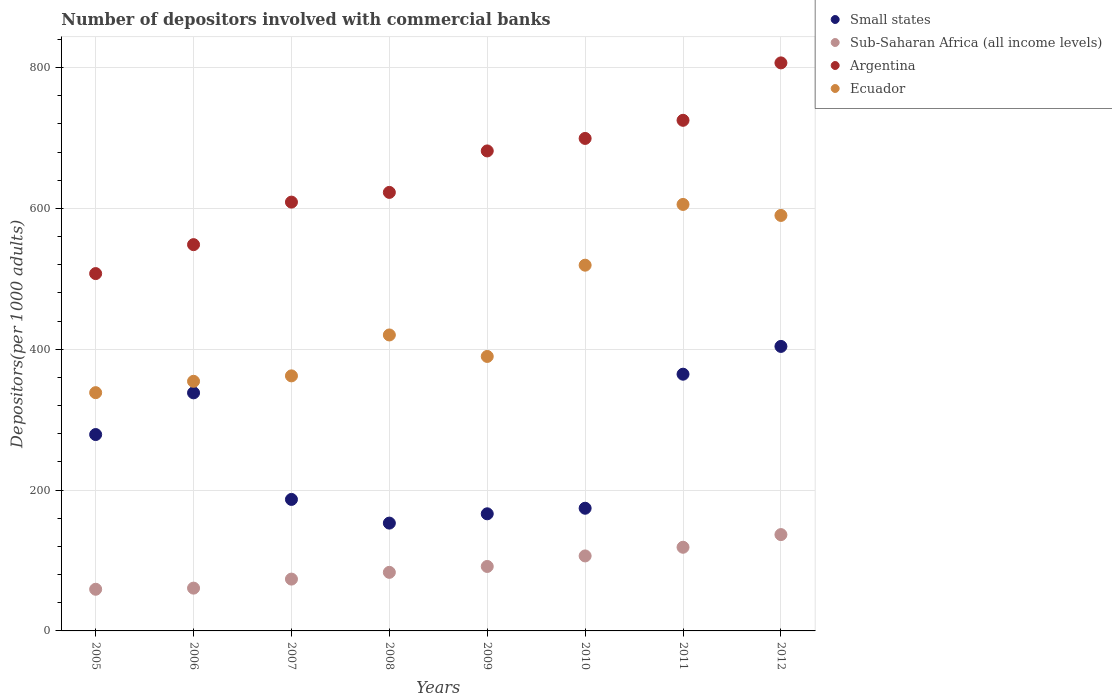How many different coloured dotlines are there?
Your answer should be very brief. 4. Is the number of dotlines equal to the number of legend labels?
Your answer should be compact. Yes. What is the number of depositors involved with commercial banks in Argentina in 2010?
Make the answer very short. 699.37. Across all years, what is the maximum number of depositors involved with commercial banks in Sub-Saharan Africa (all income levels)?
Provide a succinct answer. 136.78. Across all years, what is the minimum number of depositors involved with commercial banks in Ecuador?
Your answer should be very brief. 338.34. In which year was the number of depositors involved with commercial banks in Ecuador minimum?
Make the answer very short. 2005. What is the total number of depositors involved with commercial banks in Small states in the graph?
Offer a terse response. 2065.89. What is the difference between the number of depositors involved with commercial banks in Sub-Saharan Africa (all income levels) in 2007 and that in 2011?
Your response must be concise. -45.21. What is the difference between the number of depositors involved with commercial banks in Sub-Saharan Africa (all income levels) in 2009 and the number of depositors involved with commercial banks in Ecuador in 2010?
Keep it short and to the point. -427.82. What is the average number of depositors involved with commercial banks in Argentina per year?
Make the answer very short. 650.04. In the year 2010, what is the difference between the number of depositors involved with commercial banks in Sub-Saharan Africa (all income levels) and number of depositors involved with commercial banks in Ecuador?
Your answer should be very brief. -412.87. What is the ratio of the number of depositors involved with commercial banks in Ecuador in 2006 to that in 2007?
Give a very brief answer. 0.98. What is the difference between the highest and the second highest number of depositors involved with commercial banks in Sub-Saharan Africa (all income levels)?
Make the answer very short. 17.98. What is the difference between the highest and the lowest number of depositors involved with commercial banks in Sub-Saharan Africa (all income levels)?
Provide a short and direct response. 77.62. In how many years, is the number of depositors involved with commercial banks in Sub-Saharan Africa (all income levels) greater than the average number of depositors involved with commercial banks in Sub-Saharan Africa (all income levels) taken over all years?
Your answer should be compact. 4. Is the sum of the number of depositors involved with commercial banks in Ecuador in 2009 and 2011 greater than the maximum number of depositors involved with commercial banks in Small states across all years?
Make the answer very short. Yes. Is it the case that in every year, the sum of the number of depositors involved with commercial banks in Small states and number of depositors involved with commercial banks in Ecuador  is greater than the number of depositors involved with commercial banks in Argentina?
Keep it short and to the point. No. Does the number of depositors involved with commercial banks in Sub-Saharan Africa (all income levels) monotonically increase over the years?
Provide a succinct answer. Yes. Is the number of depositors involved with commercial banks in Sub-Saharan Africa (all income levels) strictly greater than the number of depositors involved with commercial banks in Argentina over the years?
Offer a very short reply. No. How many dotlines are there?
Provide a succinct answer. 4. How many years are there in the graph?
Your answer should be very brief. 8. What is the difference between two consecutive major ticks on the Y-axis?
Make the answer very short. 200. Are the values on the major ticks of Y-axis written in scientific E-notation?
Your response must be concise. No. Where does the legend appear in the graph?
Keep it short and to the point. Top right. How many legend labels are there?
Offer a terse response. 4. How are the legend labels stacked?
Make the answer very short. Vertical. What is the title of the graph?
Provide a short and direct response. Number of depositors involved with commercial banks. What is the label or title of the X-axis?
Keep it short and to the point. Years. What is the label or title of the Y-axis?
Make the answer very short. Depositors(per 1000 adults). What is the Depositors(per 1000 adults) of Small states in 2005?
Provide a succinct answer. 278.86. What is the Depositors(per 1000 adults) of Sub-Saharan Africa (all income levels) in 2005?
Your response must be concise. 59.17. What is the Depositors(per 1000 adults) in Argentina in 2005?
Your answer should be very brief. 507.43. What is the Depositors(per 1000 adults) in Ecuador in 2005?
Offer a very short reply. 338.34. What is the Depositors(per 1000 adults) of Small states in 2006?
Offer a terse response. 338.08. What is the Depositors(per 1000 adults) in Sub-Saharan Africa (all income levels) in 2006?
Offer a very short reply. 60.76. What is the Depositors(per 1000 adults) of Argentina in 2006?
Make the answer very short. 548.53. What is the Depositors(per 1000 adults) of Ecuador in 2006?
Ensure brevity in your answer.  354.46. What is the Depositors(per 1000 adults) of Small states in 2007?
Keep it short and to the point. 186.74. What is the Depositors(per 1000 adults) in Sub-Saharan Africa (all income levels) in 2007?
Your response must be concise. 73.6. What is the Depositors(per 1000 adults) of Argentina in 2007?
Keep it short and to the point. 608.93. What is the Depositors(per 1000 adults) in Ecuador in 2007?
Your answer should be compact. 362.19. What is the Depositors(per 1000 adults) of Small states in 2008?
Your answer should be very brief. 153.11. What is the Depositors(per 1000 adults) in Sub-Saharan Africa (all income levels) in 2008?
Give a very brief answer. 83.18. What is the Depositors(per 1000 adults) of Argentina in 2008?
Provide a succinct answer. 622.73. What is the Depositors(per 1000 adults) in Ecuador in 2008?
Ensure brevity in your answer.  420.28. What is the Depositors(per 1000 adults) in Small states in 2009?
Give a very brief answer. 166.31. What is the Depositors(per 1000 adults) of Sub-Saharan Africa (all income levels) in 2009?
Provide a succinct answer. 91.54. What is the Depositors(per 1000 adults) in Argentina in 2009?
Your response must be concise. 681.62. What is the Depositors(per 1000 adults) of Ecuador in 2009?
Ensure brevity in your answer.  389.78. What is the Depositors(per 1000 adults) in Small states in 2010?
Offer a very short reply. 174.21. What is the Depositors(per 1000 adults) in Sub-Saharan Africa (all income levels) in 2010?
Keep it short and to the point. 106.49. What is the Depositors(per 1000 adults) of Argentina in 2010?
Offer a terse response. 699.37. What is the Depositors(per 1000 adults) in Ecuador in 2010?
Make the answer very short. 519.36. What is the Depositors(per 1000 adults) in Small states in 2011?
Provide a succinct answer. 364.57. What is the Depositors(per 1000 adults) in Sub-Saharan Africa (all income levels) in 2011?
Your response must be concise. 118.8. What is the Depositors(per 1000 adults) in Argentina in 2011?
Give a very brief answer. 725.1. What is the Depositors(per 1000 adults) of Ecuador in 2011?
Provide a short and direct response. 605.63. What is the Depositors(per 1000 adults) of Small states in 2012?
Your answer should be very brief. 404.02. What is the Depositors(per 1000 adults) in Sub-Saharan Africa (all income levels) in 2012?
Provide a succinct answer. 136.78. What is the Depositors(per 1000 adults) in Argentina in 2012?
Offer a very short reply. 806.63. What is the Depositors(per 1000 adults) in Ecuador in 2012?
Offer a very short reply. 590.02. Across all years, what is the maximum Depositors(per 1000 adults) of Small states?
Your answer should be compact. 404.02. Across all years, what is the maximum Depositors(per 1000 adults) in Sub-Saharan Africa (all income levels)?
Keep it short and to the point. 136.78. Across all years, what is the maximum Depositors(per 1000 adults) in Argentina?
Your answer should be compact. 806.63. Across all years, what is the maximum Depositors(per 1000 adults) of Ecuador?
Offer a terse response. 605.63. Across all years, what is the minimum Depositors(per 1000 adults) of Small states?
Offer a terse response. 153.11. Across all years, what is the minimum Depositors(per 1000 adults) of Sub-Saharan Africa (all income levels)?
Your answer should be very brief. 59.17. Across all years, what is the minimum Depositors(per 1000 adults) in Argentina?
Make the answer very short. 507.43. Across all years, what is the minimum Depositors(per 1000 adults) in Ecuador?
Your answer should be very brief. 338.34. What is the total Depositors(per 1000 adults) in Small states in the graph?
Offer a very short reply. 2065.89. What is the total Depositors(per 1000 adults) of Sub-Saharan Africa (all income levels) in the graph?
Ensure brevity in your answer.  730.33. What is the total Depositors(per 1000 adults) of Argentina in the graph?
Provide a succinct answer. 5200.34. What is the total Depositors(per 1000 adults) of Ecuador in the graph?
Offer a terse response. 3580.07. What is the difference between the Depositors(per 1000 adults) of Small states in 2005 and that in 2006?
Your response must be concise. -59.21. What is the difference between the Depositors(per 1000 adults) of Sub-Saharan Africa (all income levels) in 2005 and that in 2006?
Offer a terse response. -1.59. What is the difference between the Depositors(per 1000 adults) in Argentina in 2005 and that in 2006?
Ensure brevity in your answer.  -41.1. What is the difference between the Depositors(per 1000 adults) of Ecuador in 2005 and that in 2006?
Ensure brevity in your answer.  -16.12. What is the difference between the Depositors(per 1000 adults) of Small states in 2005 and that in 2007?
Provide a short and direct response. 92.12. What is the difference between the Depositors(per 1000 adults) of Sub-Saharan Africa (all income levels) in 2005 and that in 2007?
Offer a very short reply. -14.43. What is the difference between the Depositors(per 1000 adults) of Argentina in 2005 and that in 2007?
Ensure brevity in your answer.  -101.5. What is the difference between the Depositors(per 1000 adults) of Ecuador in 2005 and that in 2007?
Give a very brief answer. -23.84. What is the difference between the Depositors(per 1000 adults) of Small states in 2005 and that in 2008?
Provide a short and direct response. 125.76. What is the difference between the Depositors(per 1000 adults) of Sub-Saharan Africa (all income levels) in 2005 and that in 2008?
Your answer should be very brief. -24.01. What is the difference between the Depositors(per 1000 adults) in Argentina in 2005 and that in 2008?
Your answer should be compact. -115.3. What is the difference between the Depositors(per 1000 adults) of Ecuador in 2005 and that in 2008?
Provide a succinct answer. -81.94. What is the difference between the Depositors(per 1000 adults) of Small states in 2005 and that in 2009?
Make the answer very short. 112.56. What is the difference between the Depositors(per 1000 adults) in Sub-Saharan Africa (all income levels) in 2005 and that in 2009?
Make the answer very short. -32.38. What is the difference between the Depositors(per 1000 adults) in Argentina in 2005 and that in 2009?
Offer a terse response. -174.19. What is the difference between the Depositors(per 1000 adults) of Ecuador in 2005 and that in 2009?
Offer a terse response. -51.44. What is the difference between the Depositors(per 1000 adults) of Small states in 2005 and that in 2010?
Make the answer very short. 104.65. What is the difference between the Depositors(per 1000 adults) of Sub-Saharan Africa (all income levels) in 2005 and that in 2010?
Give a very brief answer. -47.32. What is the difference between the Depositors(per 1000 adults) in Argentina in 2005 and that in 2010?
Offer a very short reply. -191.94. What is the difference between the Depositors(per 1000 adults) in Ecuador in 2005 and that in 2010?
Provide a succinct answer. -181.02. What is the difference between the Depositors(per 1000 adults) in Small states in 2005 and that in 2011?
Offer a terse response. -85.7. What is the difference between the Depositors(per 1000 adults) of Sub-Saharan Africa (all income levels) in 2005 and that in 2011?
Provide a succinct answer. -59.64. What is the difference between the Depositors(per 1000 adults) of Argentina in 2005 and that in 2011?
Your answer should be very brief. -217.67. What is the difference between the Depositors(per 1000 adults) of Ecuador in 2005 and that in 2011?
Ensure brevity in your answer.  -267.29. What is the difference between the Depositors(per 1000 adults) in Small states in 2005 and that in 2012?
Provide a short and direct response. -125.15. What is the difference between the Depositors(per 1000 adults) of Sub-Saharan Africa (all income levels) in 2005 and that in 2012?
Your response must be concise. -77.62. What is the difference between the Depositors(per 1000 adults) of Argentina in 2005 and that in 2012?
Provide a short and direct response. -299.2. What is the difference between the Depositors(per 1000 adults) of Ecuador in 2005 and that in 2012?
Your answer should be very brief. -251.68. What is the difference between the Depositors(per 1000 adults) of Small states in 2006 and that in 2007?
Your response must be concise. 151.33. What is the difference between the Depositors(per 1000 adults) of Sub-Saharan Africa (all income levels) in 2006 and that in 2007?
Your answer should be very brief. -12.83. What is the difference between the Depositors(per 1000 adults) in Argentina in 2006 and that in 2007?
Keep it short and to the point. -60.4. What is the difference between the Depositors(per 1000 adults) in Ecuador in 2006 and that in 2007?
Keep it short and to the point. -7.72. What is the difference between the Depositors(per 1000 adults) in Small states in 2006 and that in 2008?
Offer a terse response. 184.97. What is the difference between the Depositors(per 1000 adults) of Sub-Saharan Africa (all income levels) in 2006 and that in 2008?
Give a very brief answer. -22.41. What is the difference between the Depositors(per 1000 adults) in Argentina in 2006 and that in 2008?
Offer a terse response. -74.2. What is the difference between the Depositors(per 1000 adults) of Ecuador in 2006 and that in 2008?
Provide a succinct answer. -65.82. What is the difference between the Depositors(per 1000 adults) of Small states in 2006 and that in 2009?
Make the answer very short. 171.77. What is the difference between the Depositors(per 1000 adults) of Sub-Saharan Africa (all income levels) in 2006 and that in 2009?
Your response must be concise. -30.78. What is the difference between the Depositors(per 1000 adults) of Argentina in 2006 and that in 2009?
Your answer should be very brief. -133.09. What is the difference between the Depositors(per 1000 adults) of Ecuador in 2006 and that in 2009?
Your response must be concise. -35.32. What is the difference between the Depositors(per 1000 adults) of Small states in 2006 and that in 2010?
Offer a very short reply. 163.86. What is the difference between the Depositors(per 1000 adults) of Sub-Saharan Africa (all income levels) in 2006 and that in 2010?
Your answer should be compact. -45.73. What is the difference between the Depositors(per 1000 adults) of Argentina in 2006 and that in 2010?
Provide a short and direct response. -150.84. What is the difference between the Depositors(per 1000 adults) in Ecuador in 2006 and that in 2010?
Your answer should be very brief. -164.9. What is the difference between the Depositors(per 1000 adults) of Small states in 2006 and that in 2011?
Make the answer very short. -26.49. What is the difference between the Depositors(per 1000 adults) in Sub-Saharan Africa (all income levels) in 2006 and that in 2011?
Your answer should be very brief. -58.04. What is the difference between the Depositors(per 1000 adults) in Argentina in 2006 and that in 2011?
Provide a succinct answer. -176.57. What is the difference between the Depositors(per 1000 adults) in Ecuador in 2006 and that in 2011?
Ensure brevity in your answer.  -251.17. What is the difference between the Depositors(per 1000 adults) in Small states in 2006 and that in 2012?
Provide a short and direct response. -65.94. What is the difference between the Depositors(per 1000 adults) of Sub-Saharan Africa (all income levels) in 2006 and that in 2012?
Offer a very short reply. -76.02. What is the difference between the Depositors(per 1000 adults) in Argentina in 2006 and that in 2012?
Provide a succinct answer. -258.1. What is the difference between the Depositors(per 1000 adults) of Ecuador in 2006 and that in 2012?
Your answer should be very brief. -235.56. What is the difference between the Depositors(per 1000 adults) of Small states in 2007 and that in 2008?
Offer a very short reply. 33.63. What is the difference between the Depositors(per 1000 adults) of Sub-Saharan Africa (all income levels) in 2007 and that in 2008?
Offer a very short reply. -9.58. What is the difference between the Depositors(per 1000 adults) in Argentina in 2007 and that in 2008?
Your response must be concise. -13.81. What is the difference between the Depositors(per 1000 adults) in Ecuador in 2007 and that in 2008?
Give a very brief answer. -58.09. What is the difference between the Depositors(per 1000 adults) of Small states in 2007 and that in 2009?
Offer a terse response. 20.43. What is the difference between the Depositors(per 1000 adults) in Sub-Saharan Africa (all income levels) in 2007 and that in 2009?
Offer a very short reply. -17.95. What is the difference between the Depositors(per 1000 adults) in Argentina in 2007 and that in 2009?
Your answer should be compact. -72.69. What is the difference between the Depositors(per 1000 adults) of Ecuador in 2007 and that in 2009?
Your response must be concise. -27.6. What is the difference between the Depositors(per 1000 adults) in Small states in 2007 and that in 2010?
Offer a terse response. 12.53. What is the difference between the Depositors(per 1000 adults) of Sub-Saharan Africa (all income levels) in 2007 and that in 2010?
Offer a terse response. -32.89. What is the difference between the Depositors(per 1000 adults) in Argentina in 2007 and that in 2010?
Your answer should be very brief. -90.44. What is the difference between the Depositors(per 1000 adults) of Ecuador in 2007 and that in 2010?
Your answer should be compact. -157.18. What is the difference between the Depositors(per 1000 adults) in Small states in 2007 and that in 2011?
Provide a succinct answer. -177.83. What is the difference between the Depositors(per 1000 adults) in Sub-Saharan Africa (all income levels) in 2007 and that in 2011?
Your answer should be very brief. -45.21. What is the difference between the Depositors(per 1000 adults) in Argentina in 2007 and that in 2011?
Your response must be concise. -116.18. What is the difference between the Depositors(per 1000 adults) of Ecuador in 2007 and that in 2011?
Your answer should be very brief. -243.45. What is the difference between the Depositors(per 1000 adults) of Small states in 2007 and that in 2012?
Your answer should be very brief. -217.28. What is the difference between the Depositors(per 1000 adults) of Sub-Saharan Africa (all income levels) in 2007 and that in 2012?
Your answer should be very brief. -63.19. What is the difference between the Depositors(per 1000 adults) of Argentina in 2007 and that in 2012?
Offer a terse response. -197.71. What is the difference between the Depositors(per 1000 adults) in Ecuador in 2007 and that in 2012?
Your answer should be very brief. -227.83. What is the difference between the Depositors(per 1000 adults) of Small states in 2008 and that in 2009?
Your answer should be compact. -13.2. What is the difference between the Depositors(per 1000 adults) in Sub-Saharan Africa (all income levels) in 2008 and that in 2009?
Provide a short and direct response. -8.37. What is the difference between the Depositors(per 1000 adults) of Argentina in 2008 and that in 2009?
Give a very brief answer. -58.89. What is the difference between the Depositors(per 1000 adults) in Ecuador in 2008 and that in 2009?
Keep it short and to the point. 30.5. What is the difference between the Depositors(per 1000 adults) of Small states in 2008 and that in 2010?
Your answer should be very brief. -21.11. What is the difference between the Depositors(per 1000 adults) of Sub-Saharan Africa (all income levels) in 2008 and that in 2010?
Provide a succinct answer. -23.31. What is the difference between the Depositors(per 1000 adults) of Argentina in 2008 and that in 2010?
Keep it short and to the point. -76.64. What is the difference between the Depositors(per 1000 adults) in Ecuador in 2008 and that in 2010?
Provide a short and direct response. -99.08. What is the difference between the Depositors(per 1000 adults) in Small states in 2008 and that in 2011?
Make the answer very short. -211.46. What is the difference between the Depositors(per 1000 adults) of Sub-Saharan Africa (all income levels) in 2008 and that in 2011?
Ensure brevity in your answer.  -35.63. What is the difference between the Depositors(per 1000 adults) in Argentina in 2008 and that in 2011?
Give a very brief answer. -102.37. What is the difference between the Depositors(per 1000 adults) in Ecuador in 2008 and that in 2011?
Your response must be concise. -185.35. What is the difference between the Depositors(per 1000 adults) of Small states in 2008 and that in 2012?
Your response must be concise. -250.91. What is the difference between the Depositors(per 1000 adults) in Sub-Saharan Africa (all income levels) in 2008 and that in 2012?
Your answer should be compact. -53.61. What is the difference between the Depositors(per 1000 adults) in Argentina in 2008 and that in 2012?
Give a very brief answer. -183.9. What is the difference between the Depositors(per 1000 adults) in Ecuador in 2008 and that in 2012?
Provide a short and direct response. -169.74. What is the difference between the Depositors(per 1000 adults) in Small states in 2009 and that in 2010?
Your answer should be very brief. -7.91. What is the difference between the Depositors(per 1000 adults) of Sub-Saharan Africa (all income levels) in 2009 and that in 2010?
Provide a succinct answer. -14.95. What is the difference between the Depositors(per 1000 adults) in Argentina in 2009 and that in 2010?
Provide a short and direct response. -17.75. What is the difference between the Depositors(per 1000 adults) in Ecuador in 2009 and that in 2010?
Your answer should be compact. -129.58. What is the difference between the Depositors(per 1000 adults) in Small states in 2009 and that in 2011?
Offer a terse response. -198.26. What is the difference between the Depositors(per 1000 adults) of Sub-Saharan Africa (all income levels) in 2009 and that in 2011?
Provide a short and direct response. -27.26. What is the difference between the Depositors(per 1000 adults) in Argentina in 2009 and that in 2011?
Your response must be concise. -43.48. What is the difference between the Depositors(per 1000 adults) in Ecuador in 2009 and that in 2011?
Offer a terse response. -215.85. What is the difference between the Depositors(per 1000 adults) in Small states in 2009 and that in 2012?
Your answer should be very brief. -237.71. What is the difference between the Depositors(per 1000 adults) of Sub-Saharan Africa (all income levels) in 2009 and that in 2012?
Ensure brevity in your answer.  -45.24. What is the difference between the Depositors(per 1000 adults) in Argentina in 2009 and that in 2012?
Keep it short and to the point. -125.01. What is the difference between the Depositors(per 1000 adults) of Ecuador in 2009 and that in 2012?
Your answer should be very brief. -200.24. What is the difference between the Depositors(per 1000 adults) in Small states in 2010 and that in 2011?
Keep it short and to the point. -190.35. What is the difference between the Depositors(per 1000 adults) of Sub-Saharan Africa (all income levels) in 2010 and that in 2011?
Provide a succinct answer. -12.31. What is the difference between the Depositors(per 1000 adults) in Argentina in 2010 and that in 2011?
Your answer should be very brief. -25.73. What is the difference between the Depositors(per 1000 adults) in Ecuador in 2010 and that in 2011?
Give a very brief answer. -86.27. What is the difference between the Depositors(per 1000 adults) of Small states in 2010 and that in 2012?
Provide a short and direct response. -229.8. What is the difference between the Depositors(per 1000 adults) in Sub-Saharan Africa (all income levels) in 2010 and that in 2012?
Your response must be concise. -30.29. What is the difference between the Depositors(per 1000 adults) of Argentina in 2010 and that in 2012?
Provide a succinct answer. -107.26. What is the difference between the Depositors(per 1000 adults) in Ecuador in 2010 and that in 2012?
Provide a short and direct response. -70.66. What is the difference between the Depositors(per 1000 adults) in Small states in 2011 and that in 2012?
Provide a succinct answer. -39.45. What is the difference between the Depositors(per 1000 adults) in Sub-Saharan Africa (all income levels) in 2011 and that in 2012?
Make the answer very short. -17.98. What is the difference between the Depositors(per 1000 adults) in Argentina in 2011 and that in 2012?
Provide a short and direct response. -81.53. What is the difference between the Depositors(per 1000 adults) of Ecuador in 2011 and that in 2012?
Keep it short and to the point. 15.61. What is the difference between the Depositors(per 1000 adults) of Small states in 2005 and the Depositors(per 1000 adults) of Sub-Saharan Africa (all income levels) in 2006?
Ensure brevity in your answer.  218.1. What is the difference between the Depositors(per 1000 adults) of Small states in 2005 and the Depositors(per 1000 adults) of Argentina in 2006?
Your answer should be very brief. -269.67. What is the difference between the Depositors(per 1000 adults) of Small states in 2005 and the Depositors(per 1000 adults) of Ecuador in 2006?
Your answer should be compact. -75.6. What is the difference between the Depositors(per 1000 adults) of Sub-Saharan Africa (all income levels) in 2005 and the Depositors(per 1000 adults) of Argentina in 2006?
Ensure brevity in your answer.  -489.36. What is the difference between the Depositors(per 1000 adults) of Sub-Saharan Africa (all income levels) in 2005 and the Depositors(per 1000 adults) of Ecuador in 2006?
Make the answer very short. -295.3. What is the difference between the Depositors(per 1000 adults) in Argentina in 2005 and the Depositors(per 1000 adults) in Ecuador in 2006?
Offer a very short reply. 152.97. What is the difference between the Depositors(per 1000 adults) of Small states in 2005 and the Depositors(per 1000 adults) of Sub-Saharan Africa (all income levels) in 2007?
Keep it short and to the point. 205.27. What is the difference between the Depositors(per 1000 adults) of Small states in 2005 and the Depositors(per 1000 adults) of Argentina in 2007?
Provide a short and direct response. -330.06. What is the difference between the Depositors(per 1000 adults) of Small states in 2005 and the Depositors(per 1000 adults) of Ecuador in 2007?
Your answer should be compact. -83.32. What is the difference between the Depositors(per 1000 adults) in Sub-Saharan Africa (all income levels) in 2005 and the Depositors(per 1000 adults) in Argentina in 2007?
Offer a terse response. -549.76. What is the difference between the Depositors(per 1000 adults) in Sub-Saharan Africa (all income levels) in 2005 and the Depositors(per 1000 adults) in Ecuador in 2007?
Provide a succinct answer. -303.02. What is the difference between the Depositors(per 1000 adults) of Argentina in 2005 and the Depositors(per 1000 adults) of Ecuador in 2007?
Offer a very short reply. 145.24. What is the difference between the Depositors(per 1000 adults) of Small states in 2005 and the Depositors(per 1000 adults) of Sub-Saharan Africa (all income levels) in 2008?
Your answer should be compact. 195.69. What is the difference between the Depositors(per 1000 adults) in Small states in 2005 and the Depositors(per 1000 adults) in Argentina in 2008?
Offer a very short reply. -343.87. What is the difference between the Depositors(per 1000 adults) in Small states in 2005 and the Depositors(per 1000 adults) in Ecuador in 2008?
Your response must be concise. -141.42. What is the difference between the Depositors(per 1000 adults) of Sub-Saharan Africa (all income levels) in 2005 and the Depositors(per 1000 adults) of Argentina in 2008?
Ensure brevity in your answer.  -563.56. What is the difference between the Depositors(per 1000 adults) in Sub-Saharan Africa (all income levels) in 2005 and the Depositors(per 1000 adults) in Ecuador in 2008?
Your answer should be compact. -361.11. What is the difference between the Depositors(per 1000 adults) in Argentina in 2005 and the Depositors(per 1000 adults) in Ecuador in 2008?
Provide a succinct answer. 87.15. What is the difference between the Depositors(per 1000 adults) in Small states in 2005 and the Depositors(per 1000 adults) in Sub-Saharan Africa (all income levels) in 2009?
Ensure brevity in your answer.  187.32. What is the difference between the Depositors(per 1000 adults) in Small states in 2005 and the Depositors(per 1000 adults) in Argentina in 2009?
Offer a terse response. -402.75. What is the difference between the Depositors(per 1000 adults) in Small states in 2005 and the Depositors(per 1000 adults) in Ecuador in 2009?
Give a very brief answer. -110.92. What is the difference between the Depositors(per 1000 adults) of Sub-Saharan Africa (all income levels) in 2005 and the Depositors(per 1000 adults) of Argentina in 2009?
Provide a succinct answer. -622.45. What is the difference between the Depositors(per 1000 adults) of Sub-Saharan Africa (all income levels) in 2005 and the Depositors(per 1000 adults) of Ecuador in 2009?
Provide a short and direct response. -330.62. What is the difference between the Depositors(per 1000 adults) in Argentina in 2005 and the Depositors(per 1000 adults) in Ecuador in 2009?
Offer a terse response. 117.65. What is the difference between the Depositors(per 1000 adults) of Small states in 2005 and the Depositors(per 1000 adults) of Sub-Saharan Africa (all income levels) in 2010?
Your response must be concise. 172.37. What is the difference between the Depositors(per 1000 adults) in Small states in 2005 and the Depositors(per 1000 adults) in Argentina in 2010?
Offer a very short reply. -420.51. What is the difference between the Depositors(per 1000 adults) in Small states in 2005 and the Depositors(per 1000 adults) in Ecuador in 2010?
Your answer should be very brief. -240.5. What is the difference between the Depositors(per 1000 adults) in Sub-Saharan Africa (all income levels) in 2005 and the Depositors(per 1000 adults) in Argentina in 2010?
Your answer should be compact. -640.2. What is the difference between the Depositors(per 1000 adults) in Sub-Saharan Africa (all income levels) in 2005 and the Depositors(per 1000 adults) in Ecuador in 2010?
Your response must be concise. -460.2. What is the difference between the Depositors(per 1000 adults) of Argentina in 2005 and the Depositors(per 1000 adults) of Ecuador in 2010?
Provide a short and direct response. -11.93. What is the difference between the Depositors(per 1000 adults) in Small states in 2005 and the Depositors(per 1000 adults) in Sub-Saharan Africa (all income levels) in 2011?
Make the answer very short. 160.06. What is the difference between the Depositors(per 1000 adults) in Small states in 2005 and the Depositors(per 1000 adults) in Argentina in 2011?
Offer a terse response. -446.24. What is the difference between the Depositors(per 1000 adults) of Small states in 2005 and the Depositors(per 1000 adults) of Ecuador in 2011?
Provide a succinct answer. -326.77. What is the difference between the Depositors(per 1000 adults) of Sub-Saharan Africa (all income levels) in 2005 and the Depositors(per 1000 adults) of Argentina in 2011?
Your answer should be very brief. -665.93. What is the difference between the Depositors(per 1000 adults) in Sub-Saharan Africa (all income levels) in 2005 and the Depositors(per 1000 adults) in Ecuador in 2011?
Offer a terse response. -546.47. What is the difference between the Depositors(per 1000 adults) in Argentina in 2005 and the Depositors(per 1000 adults) in Ecuador in 2011?
Give a very brief answer. -98.2. What is the difference between the Depositors(per 1000 adults) in Small states in 2005 and the Depositors(per 1000 adults) in Sub-Saharan Africa (all income levels) in 2012?
Offer a terse response. 142.08. What is the difference between the Depositors(per 1000 adults) of Small states in 2005 and the Depositors(per 1000 adults) of Argentina in 2012?
Your answer should be very brief. -527.77. What is the difference between the Depositors(per 1000 adults) in Small states in 2005 and the Depositors(per 1000 adults) in Ecuador in 2012?
Your response must be concise. -311.16. What is the difference between the Depositors(per 1000 adults) in Sub-Saharan Africa (all income levels) in 2005 and the Depositors(per 1000 adults) in Argentina in 2012?
Provide a short and direct response. -747.46. What is the difference between the Depositors(per 1000 adults) of Sub-Saharan Africa (all income levels) in 2005 and the Depositors(per 1000 adults) of Ecuador in 2012?
Your answer should be very brief. -530.85. What is the difference between the Depositors(per 1000 adults) of Argentina in 2005 and the Depositors(per 1000 adults) of Ecuador in 2012?
Give a very brief answer. -82.59. What is the difference between the Depositors(per 1000 adults) in Small states in 2006 and the Depositors(per 1000 adults) in Sub-Saharan Africa (all income levels) in 2007?
Your answer should be very brief. 264.48. What is the difference between the Depositors(per 1000 adults) of Small states in 2006 and the Depositors(per 1000 adults) of Argentina in 2007?
Your response must be concise. -270.85. What is the difference between the Depositors(per 1000 adults) of Small states in 2006 and the Depositors(per 1000 adults) of Ecuador in 2007?
Your answer should be compact. -24.11. What is the difference between the Depositors(per 1000 adults) of Sub-Saharan Africa (all income levels) in 2006 and the Depositors(per 1000 adults) of Argentina in 2007?
Offer a very short reply. -548.16. What is the difference between the Depositors(per 1000 adults) in Sub-Saharan Africa (all income levels) in 2006 and the Depositors(per 1000 adults) in Ecuador in 2007?
Your answer should be compact. -301.42. What is the difference between the Depositors(per 1000 adults) in Argentina in 2006 and the Depositors(per 1000 adults) in Ecuador in 2007?
Provide a short and direct response. 186.34. What is the difference between the Depositors(per 1000 adults) of Small states in 2006 and the Depositors(per 1000 adults) of Sub-Saharan Africa (all income levels) in 2008?
Ensure brevity in your answer.  254.9. What is the difference between the Depositors(per 1000 adults) of Small states in 2006 and the Depositors(per 1000 adults) of Argentina in 2008?
Provide a succinct answer. -284.66. What is the difference between the Depositors(per 1000 adults) in Small states in 2006 and the Depositors(per 1000 adults) in Ecuador in 2008?
Offer a terse response. -82.2. What is the difference between the Depositors(per 1000 adults) in Sub-Saharan Africa (all income levels) in 2006 and the Depositors(per 1000 adults) in Argentina in 2008?
Keep it short and to the point. -561.97. What is the difference between the Depositors(per 1000 adults) in Sub-Saharan Africa (all income levels) in 2006 and the Depositors(per 1000 adults) in Ecuador in 2008?
Keep it short and to the point. -359.52. What is the difference between the Depositors(per 1000 adults) of Argentina in 2006 and the Depositors(per 1000 adults) of Ecuador in 2008?
Your response must be concise. 128.25. What is the difference between the Depositors(per 1000 adults) of Small states in 2006 and the Depositors(per 1000 adults) of Sub-Saharan Africa (all income levels) in 2009?
Keep it short and to the point. 246.53. What is the difference between the Depositors(per 1000 adults) of Small states in 2006 and the Depositors(per 1000 adults) of Argentina in 2009?
Keep it short and to the point. -343.54. What is the difference between the Depositors(per 1000 adults) in Small states in 2006 and the Depositors(per 1000 adults) in Ecuador in 2009?
Your response must be concise. -51.71. What is the difference between the Depositors(per 1000 adults) of Sub-Saharan Africa (all income levels) in 2006 and the Depositors(per 1000 adults) of Argentina in 2009?
Make the answer very short. -620.86. What is the difference between the Depositors(per 1000 adults) of Sub-Saharan Africa (all income levels) in 2006 and the Depositors(per 1000 adults) of Ecuador in 2009?
Your response must be concise. -329.02. What is the difference between the Depositors(per 1000 adults) of Argentina in 2006 and the Depositors(per 1000 adults) of Ecuador in 2009?
Offer a very short reply. 158.75. What is the difference between the Depositors(per 1000 adults) in Small states in 2006 and the Depositors(per 1000 adults) in Sub-Saharan Africa (all income levels) in 2010?
Make the answer very short. 231.59. What is the difference between the Depositors(per 1000 adults) in Small states in 2006 and the Depositors(per 1000 adults) in Argentina in 2010?
Provide a short and direct response. -361.29. What is the difference between the Depositors(per 1000 adults) in Small states in 2006 and the Depositors(per 1000 adults) in Ecuador in 2010?
Your answer should be compact. -181.29. What is the difference between the Depositors(per 1000 adults) in Sub-Saharan Africa (all income levels) in 2006 and the Depositors(per 1000 adults) in Argentina in 2010?
Provide a short and direct response. -638.61. What is the difference between the Depositors(per 1000 adults) in Sub-Saharan Africa (all income levels) in 2006 and the Depositors(per 1000 adults) in Ecuador in 2010?
Keep it short and to the point. -458.6. What is the difference between the Depositors(per 1000 adults) of Argentina in 2006 and the Depositors(per 1000 adults) of Ecuador in 2010?
Offer a terse response. 29.17. What is the difference between the Depositors(per 1000 adults) of Small states in 2006 and the Depositors(per 1000 adults) of Sub-Saharan Africa (all income levels) in 2011?
Ensure brevity in your answer.  219.27. What is the difference between the Depositors(per 1000 adults) of Small states in 2006 and the Depositors(per 1000 adults) of Argentina in 2011?
Provide a succinct answer. -387.03. What is the difference between the Depositors(per 1000 adults) of Small states in 2006 and the Depositors(per 1000 adults) of Ecuador in 2011?
Give a very brief answer. -267.56. What is the difference between the Depositors(per 1000 adults) in Sub-Saharan Africa (all income levels) in 2006 and the Depositors(per 1000 adults) in Argentina in 2011?
Make the answer very short. -664.34. What is the difference between the Depositors(per 1000 adults) in Sub-Saharan Africa (all income levels) in 2006 and the Depositors(per 1000 adults) in Ecuador in 2011?
Your answer should be compact. -544.87. What is the difference between the Depositors(per 1000 adults) of Argentina in 2006 and the Depositors(per 1000 adults) of Ecuador in 2011?
Your answer should be very brief. -57.1. What is the difference between the Depositors(per 1000 adults) of Small states in 2006 and the Depositors(per 1000 adults) of Sub-Saharan Africa (all income levels) in 2012?
Provide a succinct answer. 201.29. What is the difference between the Depositors(per 1000 adults) of Small states in 2006 and the Depositors(per 1000 adults) of Argentina in 2012?
Provide a succinct answer. -468.56. What is the difference between the Depositors(per 1000 adults) of Small states in 2006 and the Depositors(per 1000 adults) of Ecuador in 2012?
Provide a succinct answer. -251.94. What is the difference between the Depositors(per 1000 adults) in Sub-Saharan Africa (all income levels) in 2006 and the Depositors(per 1000 adults) in Argentina in 2012?
Your response must be concise. -745.87. What is the difference between the Depositors(per 1000 adults) of Sub-Saharan Africa (all income levels) in 2006 and the Depositors(per 1000 adults) of Ecuador in 2012?
Keep it short and to the point. -529.26. What is the difference between the Depositors(per 1000 adults) of Argentina in 2006 and the Depositors(per 1000 adults) of Ecuador in 2012?
Provide a succinct answer. -41.49. What is the difference between the Depositors(per 1000 adults) of Small states in 2007 and the Depositors(per 1000 adults) of Sub-Saharan Africa (all income levels) in 2008?
Provide a succinct answer. 103.56. What is the difference between the Depositors(per 1000 adults) of Small states in 2007 and the Depositors(per 1000 adults) of Argentina in 2008?
Your response must be concise. -435.99. What is the difference between the Depositors(per 1000 adults) in Small states in 2007 and the Depositors(per 1000 adults) in Ecuador in 2008?
Make the answer very short. -233.54. What is the difference between the Depositors(per 1000 adults) in Sub-Saharan Africa (all income levels) in 2007 and the Depositors(per 1000 adults) in Argentina in 2008?
Offer a terse response. -549.14. What is the difference between the Depositors(per 1000 adults) of Sub-Saharan Africa (all income levels) in 2007 and the Depositors(per 1000 adults) of Ecuador in 2008?
Your answer should be very brief. -346.68. What is the difference between the Depositors(per 1000 adults) in Argentina in 2007 and the Depositors(per 1000 adults) in Ecuador in 2008?
Make the answer very short. 188.65. What is the difference between the Depositors(per 1000 adults) of Small states in 2007 and the Depositors(per 1000 adults) of Sub-Saharan Africa (all income levels) in 2009?
Keep it short and to the point. 95.2. What is the difference between the Depositors(per 1000 adults) in Small states in 2007 and the Depositors(per 1000 adults) in Argentina in 2009?
Keep it short and to the point. -494.88. What is the difference between the Depositors(per 1000 adults) of Small states in 2007 and the Depositors(per 1000 adults) of Ecuador in 2009?
Give a very brief answer. -203.04. What is the difference between the Depositors(per 1000 adults) in Sub-Saharan Africa (all income levels) in 2007 and the Depositors(per 1000 adults) in Argentina in 2009?
Your answer should be compact. -608.02. What is the difference between the Depositors(per 1000 adults) in Sub-Saharan Africa (all income levels) in 2007 and the Depositors(per 1000 adults) in Ecuador in 2009?
Ensure brevity in your answer.  -316.19. What is the difference between the Depositors(per 1000 adults) of Argentina in 2007 and the Depositors(per 1000 adults) of Ecuador in 2009?
Offer a terse response. 219.14. What is the difference between the Depositors(per 1000 adults) in Small states in 2007 and the Depositors(per 1000 adults) in Sub-Saharan Africa (all income levels) in 2010?
Give a very brief answer. 80.25. What is the difference between the Depositors(per 1000 adults) of Small states in 2007 and the Depositors(per 1000 adults) of Argentina in 2010?
Keep it short and to the point. -512.63. What is the difference between the Depositors(per 1000 adults) of Small states in 2007 and the Depositors(per 1000 adults) of Ecuador in 2010?
Give a very brief answer. -332.62. What is the difference between the Depositors(per 1000 adults) of Sub-Saharan Africa (all income levels) in 2007 and the Depositors(per 1000 adults) of Argentina in 2010?
Your response must be concise. -625.77. What is the difference between the Depositors(per 1000 adults) of Sub-Saharan Africa (all income levels) in 2007 and the Depositors(per 1000 adults) of Ecuador in 2010?
Offer a very short reply. -445.77. What is the difference between the Depositors(per 1000 adults) of Argentina in 2007 and the Depositors(per 1000 adults) of Ecuador in 2010?
Give a very brief answer. 89.56. What is the difference between the Depositors(per 1000 adults) of Small states in 2007 and the Depositors(per 1000 adults) of Sub-Saharan Africa (all income levels) in 2011?
Make the answer very short. 67.94. What is the difference between the Depositors(per 1000 adults) of Small states in 2007 and the Depositors(per 1000 adults) of Argentina in 2011?
Keep it short and to the point. -538.36. What is the difference between the Depositors(per 1000 adults) in Small states in 2007 and the Depositors(per 1000 adults) in Ecuador in 2011?
Your answer should be very brief. -418.89. What is the difference between the Depositors(per 1000 adults) in Sub-Saharan Africa (all income levels) in 2007 and the Depositors(per 1000 adults) in Argentina in 2011?
Your answer should be compact. -651.51. What is the difference between the Depositors(per 1000 adults) in Sub-Saharan Africa (all income levels) in 2007 and the Depositors(per 1000 adults) in Ecuador in 2011?
Offer a terse response. -532.04. What is the difference between the Depositors(per 1000 adults) of Argentina in 2007 and the Depositors(per 1000 adults) of Ecuador in 2011?
Your answer should be compact. 3.29. What is the difference between the Depositors(per 1000 adults) in Small states in 2007 and the Depositors(per 1000 adults) in Sub-Saharan Africa (all income levels) in 2012?
Your response must be concise. 49.96. What is the difference between the Depositors(per 1000 adults) of Small states in 2007 and the Depositors(per 1000 adults) of Argentina in 2012?
Ensure brevity in your answer.  -619.89. What is the difference between the Depositors(per 1000 adults) of Small states in 2007 and the Depositors(per 1000 adults) of Ecuador in 2012?
Offer a very short reply. -403.28. What is the difference between the Depositors(per 1000 adults) of Sub-Saharan Africa (all income levels) in 2007 and the Depositors(per 1000 adults) of Argentina in 2012?
Make the answer very short. -733.04. What is the difference between the Depositors(per 1000 adults) of Sub-Saharan Africa (all income levels) in 2007 and the Depositors(per 1000 adults) of Ecuador in 2012?
Offer a very short reply. -516.42. What is the difference between the Depositors(per 1000 adults) of Argentina in 2007 and the Depositors(per 1000 adults) of Ecuador in 2012?
Provide a succinct answer. 18.91. What is the difference between the Depositors(per 1000 adults) in Small states in 2008 and the Depositors(per 1000 adults) in Sub-Saharan Africa (all income levels) in 2009?
Ensure brevity in your answer.  61.56. What is the difference between the Depositors(per 1000 adults) of Small states in 2008 and the Depositors(per 1000 adults) of Argentina in 2009?
Your answer should be compact. -528.51. What is the difference between the Depositors(per 1000 adults) in Small states in 2008 and the Depositors(per 1000 adults) in Ecuador in 2009?
Ensure brevity in your answer.  -236.68. What is the difference between the Depositors(per 1000 adults) in Sub-Saharan Africa (all income levels) in 2008 and the Depositors(per 1000 adults) in Argentina in 2009?
Your answer should be very brief. -598.44. What is the difference between the Depositors(per 1000 adults) in Sub-Saharan Africa (all income levels) in 2008 and the Depositors(per 1000 adults) in Ecuador in 2009?
Provide a short and direct response. -306.61. What is the difference between the Depositors(per 1000 adults) in Argentina in 2008 and the Depositors(per 1000 adults) in Ecuador in 2009?
Keep it short and to the point. 232.95. What is the difference between the Depositors(per 1000 adults) of Small states in 2008 and the Depositors(per 1000 adults) of Sub-Saharan Africa (all income levels) in 2010?
Give a very brief answer. 46.62. What is the difference between the Depositors(per 1000 adults) in Small states in 2008 and the Depositors(per 1000 adults) in Argentina in 2010?
Your answer should be compact. -546.26. What is the difference between the Depositors(per 1000 adults) of Small states in 2008 and the Depositors(per 1000 adults) of Ecuador in 2010?
Make the answer very short. -366.26. What is the difference between the Depositors(per 1000 adults) of Sub-Saharan Africa (all income levels) in 2008 and the Depositors(per 1000 adults) of Argentina in 2010?
Provide a succinct answer. -616.19. What is the difference between the Depositors(per 1000 adults) in Sub-Saharan Africa (all income levels) in 2008 and the Depositors(per 1000 adults) in Ecuador in 2010?
Keep it short and to the point. -436.19. What is the difference between the Depositors(per 1000 adults) in Argentina in 2008 and the Depositors(per 1000 adults) in Ecuador in 2010?
Give a very brief answer. 103.37. What is the difference between the Depositors(per 1000 adults) in Small states in 2008 and the Depositors(per 1000 adults) in Sub-Saharan Africa (all income levels) in 2011?
Your response must be concise. 34.3. What is the difference between the Depositors(per 1000 adults) in Small states in 2008 and the Depositors(per 1000 adults) in Argentina in 2011?
Ensure brevity in your answer.  -572. What is the difference between the Depositors(per 1000 adults) in Small states in 2008 and the Depositors(per 1000 adults) in Ecuador in 2011?
Give a very brief answer. -452.53. What is the difference between the Depositors(per 1000 adults) of Sub-Saharan Africa (all income levels) in 2008 and the Depositors(per 1000 adults) of Argentina in 2011?
Make the answer very short. -641.93. What is the difference between the Depositors(per 1000 adults) in Sub-Saharan Africa (all income levels) in 2008 and the Depositors(per 1000 adults) in Ecuador in 2011?
Offer a terse response. -522.46. What is the difference between the Depositors(per 1000 adults) in Argentina in 2008 and the Depositors(per 1000 adults) in Ecuador in 2011?
Give a very brief answer. 17.1. What is the difference between the Depositors(per 1000 adults) of Small states in 2008 and the Depositors(per 1000 adults) of Sub-Saharan Africa (all income levels) in 2012?
Offer a very short reply. 16.32. What is the difference between the Depositors(per 1000 adults) of Small states in 2008 and the Depositors(per 1000 adults) of Argentina in 2012?
Keep it short and to the point. -653.53. What is the difference between the Depositors(per 1000 adults) in Small states in 2008 and the Depositors(per 1000 adults) in Ecuador in 2012?
Make the answer very short. -436.91. What is the difference between the Depositors(per 1000 adults) of Sub-Saharan Africa (all income levels) in 2008 and the Depositors(per 1000 adults) of Argentina in 2012?
Make the answer very short. -723.46. What is the difference between the Depositors(per 1000 adults) of Sub-Saharan Africa (all income levels) in 2008 and the Depositors(per 1000 adults) of Ecuador in 2012?
Provide a succinct answer. -506.84. What is the difference between the Depositors(per 1000 adults) in Argentina in 2008 and the Depositors(per 1000 adults) in Ecuador in 2012?
Your response must be concise. 32.71. What is the difference between the Depositors(per 1000 adults) in Small states in 2009 and the Depositors(per 1000 adults) in Sub-Saharan Africa (all income levels) in 2010?
Offer a very short reply. 59.82. What is the difference between the Depositors(per 1000 adults) in Small states in 2009 and the Depositors(per 1000 adults) in Argentina in 2010?
Keep it short and to the point. -533.06. What is the difference between the Depositors(per 1000 adults) in Small states in 2009 and the Depositors(per 1000 adults) in Ecuador in 2010?
Provide a short and direct response. -353.06. What is the difference between the Depositors(per 1000 adults) of Sub-Saharan Africa (all income levels) in 2009 and the Depositors(per 1000 adults) of Argentina in 2010?
Provide a short and direct response. -607.83. What is the difference between the Depositors(per 1000 adults) of Sub-Saharan Africa (all income levels) in 2009 and the Depositors(per 1000 adults) of Ecuador in 2010?
Ensure brevity in your answer.  -427.82. What is the difference between the Depositors(per 1000 adults) in Argentina in 2009 and the Depositors(per 1000 adults) in Ecuador in 2010?
Keep it short and to the point. 162.25. What is the difference between the Depositors(per 1000 adults) in Small states in 2009 and the Depositors(per 1000 adults) in Sub-Saharan Africa (all income levels) in 2011?
Your answer should be very brief. 47.5. What is the difference between the Depositors(per 1000 adults) in Small states in 2009 and the Depositors(per 1000 adults) in Argentina in 2011?
Give a very brief answer. -558.8. What is the difference between the Depositors(per 1000 adults) of Small states in 2009 and the Depositors(per 1000 adults) of Ecuador in 2011?
Make the answer very short. -439.33. What is the difference between the Depositors(per 1000 adults) in Sub-Saharan Africa (all income levels) in 2009 and the Depositors(per 1000 adults) in Argentina in 2011?
Your answer should be very brief. -633.56. What is the difference between the Depositors(per 1000 adults) of Sub-Saharan Africa (all income levels) in 2009 and the Depositors(per 1000 adults) of Ecuador in 2011?
Your answer should be compact. -514.09. What is the difference between the Depositors(per 1000 adults) in Argentina in 2009 and the Depositors(per 1000 adults) in Ecuador in 2011?
Make the answer very short. 75.98. What is the difference between the Depositors(per 1000 adults) of Small states in 2009 and the Depositors(per 1000 adults) of Sub-Saharan Africa (all income levels) in 2012?
Your answer should be very brief. 29.52. What is the difference between the Depositors(per 1000 adults) of Small states in 2009 and the Depositors(per 1000 adults) of Argentina in 2012?
Give a very brief answer. -640.33. What is the difference between the Depositors(per 1000 adults) of Small states in 2009 and the Depositors(per 1000 adults) of Ecuador in 2012?
Your answer should be very brief. -423.71. What is the difference between the Depositors(per 1000 adults) in Sub-Saharan Africa (all income levels) in 2009 and the Depositors(per 1000 adults) in Argentina in 2012?
Offer a very short reply. -715.09. What is the difference between the Depositors(per 1000 adults) in Sub-Saharan Africa (all income levels) in 2009 and the Depositors(per 1000 adults) in Ecuador in 2012?
Give a very brief answer. -498.48. What is the difference between the Depositors(per 1000 adults) in Argentina in 2009 and the Depositors(per 1000 adults) in Ecuador in 2012?
Offer a very short reply. 91.6. What is the difference between the Depositors(per 1000 adults) of Small states in 2010 and the Depositors(per 1000 adults) of Sub-Saharan Africa (all income levels) in 2011?
Provide a succinct answer. 55.41. What is the difference between the Depositors(per 1000 adults) of Small states in 2010 and the Depositors(per 1000 adults) of Argentina in 2011?
Offer a terse response. -550.89. What is the difference between the Depositors(per 1000 adults) in Small states in 2010 and the Depositors(per 1000 adults) in Ecuador in 2011?
Provide a short and direct response. -431.42. What is the difference between the Depositors(per 1000 adults) of Sub-Saharan Africa (all income levels) in 2010 and the Depositors(per 1000 adults) of Argentina in 2011?
Provide a short and direct response. -618.61. What is the difference between the Depositors(per 1000 adults) of Sub-Saharan Africa (all income levels) in 2010 and the Depositors(per 1000 adults) of Ecuador in 2011?
Provide a succinct answer. -499.14. What is the difference between the Depositors(per 1000 adults) of Argentina in 2010 and the Depositors(per 1000 adults) of Ecuador in 2011?
Your answer should be very brief. 93.74. What is the difference between the Depositors(per 1000 adults) in Small states in 2010 and the Depositors(per 1000 adults) in Sub-Saharan Africa (all income levels) in 2012?
Provide a succinct answer. 37.43. What is the difference between the Depositors(per 1000 adults) of Small states in 2010 and the Depositors(per 1000 adults) of Argentina in 2012?
Offer a terse response. -632.42. What is the difference between the Depositors(per 1000 adults) in Small states in 2010 and the Depositors(per 1000 adults) in Ecuador in 2012?
Provide a succinct answer. -415.81. What is the difference between the Depositors(per 1000 adults) in Sub-Saharan Africa (all income levels) in 2010 and the Depositors(per 1000 adults) in Argentina in 2012?
Provide a succinct answer. -700.14. What is the difference between the Depositors(per 1000 adults) in Sub-Saharan Africa (all income levels) in 2010 and the Depositors(per 1000 adults) in Ecuador in 2012?
Your answer should be very brief. -483.53. What is the difference between the Depositors(per 1000 adults) of Argentina in 2010 and the Depositors(per 1000 adults) of Ecuador in 2012?
Your answer should be very brief. 109.35. What is the difference between the Depositors(per 1000 adults) in Small states in 2011 and the Depositors(per 1000 adults) in Sub-Saharan Africa (all income levels) in 2012?
Ensure brevity in your answer.  227.78. What is the difference between the Depositors(per 1000 adults) of Small states in 2011 and the Depositors(per 1000 adults) of Argentina in 2012?
Provide a succinct answer. -442.06. What is the difference between the Depositors(per 1000 adults) of Small states in 2011 and the Depositors(per 1000 adults) of Ecuador in 2012?
Your answer should be compact. -225.45. What is the difference between the Depositors(per 1000 adults) in Sub-Saharan Africa (all income levels) in 2011 and the Depositors(per 1000 adults) in Argentina in 2012?
Your response must be concise. -687.83. What is the difference between the Depositors(per 1000 adults) of Sub-Saharan Africa (all income levels) in 2011 and the Depositors(per 1000 adults) of Ecuador in 2012?
Provide a short and direct response. -471.22. What is the difference between the Depositors(per 1000 adults) of Argentina in 2011 and the Depositors(per 1000 adults) of Ecuador in 2012?
Ensure brevity in your answer.  135.08. What is the average Depositors(per 1000 adults) in Small states per year?
Offer a very short reply. 258.24. What is the average Depositors(per 1000 adults) in Sub-Saharan Africa (all income levels) per year?
Give a very brief answer. 91.29. What is the average Depositors(per 1000 adults) of Argentina per year?
Offer a very short reply. 650.04. What is the average Depositors(per 1000 adults) in Ecuador per year?
Your answer should be compact. 447.51. In the year 2005, what is the difference between the Depositors(per 1000 adults) in Small states and Depositors(per 1000 adults) in Sub-Saharan Africa (all income levels)?
Your answer should be very brief. 219.7. In the year 2005, what is the difference between the Depositors(per 1000 adults) of Small states and Depositors(per 1000 adults) of Argentina?
Offer a terse response. -228.57. In the year 2005, what is the difference between the Depositors(per 1000 adults) in Small states and Depositors(per 1000 adults) in Ecuador?
Offer a very short reply. -59.48. In the year 2005, what is the difference between the Depositors(per 1000 adults) in Sub-Saharan Africa (all income levels) and Depositors(per 1000 adults) in Argentina?
Give a very brief answer. -448.26. In the year 2005, what is the difference between the Depositors(per 1000 adults) of Sub-Saharan Africa (all income levels) and Depositors(per 1000 adults) of Ecuador?
Ensure brevity in your answer.  -279.17. In the year 2005, what is the difference between the Depositors(per 1000 adults) of Argentina and Depositors(per 1000 adults) of Ecuador?
Your response must be concise. 169.09. In the year 2006, what is the difference between the Depositors(per 1000 adults) of Small states and Depositors(per 1000 adults) of Sub-Saharan Africa (all income levels)?
Provide a succinct answer. 277.31. In the year 2006, what is the difference between the Depositors(per 1000 adults) in Small states and Depositors(per 1000 adults) in Argentina?
Your answer should be very brief. -210.45. In the year 2006, what is the difference between the Depositors(per 1000 adults) in Small states and Depositors(per 1000 adults) in Ecuador?
Keep it short and to the point. -16.39. In the year 2006, what is the difference between the Depositors(per 1000 adults) of Sub-Saharan Africa (all income levels) and Depositors(per 1000 adults) of Argentina?
Offer a terse response. -487.77. In the year 2006, what is the difference between the Depositors(per 1000 adults) of Sub-Saharan Africa (all income levels) and Depositors(per 1000 adults) of Ecuador?
Keep it short and to the point. -293.7. In the year 2006, what is the difference between the Depositors(per 1000 adults) of Argentina and Depositors(per 1000 adults) of Ecuador?
Offer a very short reply. 194.07. In the year 2007, what is the difference between the Depositors(per 1000 adults) of Small states and Depositors(per 1000 adults) of Sub-Saharan Africa (all income levels)?
Make the answer very short. 113.14. In the year 2007, what is the difference between the Depositors(per 1000 adults) in Small states and Depositors(per 1000 adults) in Argentina?
Ensure brevity in your answer.  -422.18. In the year 2007, what is the difference between the Depositors(per 1000 adults) in Small states and Depositors(per 1000 adults) in Ecuador?
Ensure brevity in your answer.  -175.44. In the year 2007, what is the difference between the Depositors(per 1000 adults) of Sub-Saharan Africa (all income levels) and Depositors(per 1000 adults) of Argentina?
Make the answer very short. -535.33. In the year 2007, what is the difference between the Depositors(per 1000 adults) in Sub-Saharan Africa (all income levels) and Depositors(per 1000 adults) in Ecuador?
Offer a terse response. -288.59. In the year 2007, what is the difference between the Depositors(per 1000 adults) in Argentina and Depositors(per 1000 adults) in Ecuador?
Offer a terse response. 246.74. In the year 2008, what is the difference between the Depositors(per 1000 adults) of Small states and Depositors(per 1000 adults) of Sub-Saharan Africa (all income levels)?
Provide a succinct answer. 69.93. In the year 2008, what is the difference between the Depositors(per 1000 adults) of Small states and Depositors(per 1000 adults) of Argentina?
Give a very brief answer. -469.63. In the year 2008, what is the difference between the Depositors(per 1000 adults) in Small states and Depositors(per 1000 adults) in Ecuador?
Offer a very short reply. -267.17. In the year 2008, what is the difference between the Depositors(per 1000 adults) of Sub-Saharan Africa (all income levels) and Depositors(per 1000 adults) of Argentina?
Provide a succinct answer. -539.56. In the year 2008, what is the difference between the Depositors(per 1000 adults) of Sub-Saharan Africa (all income levels) and Depositors(per 1000 adults) of Ecuador?
Your answer should be compact. -337.1. In the year 2008, what is the difference between the Depositors(per 1000 adults) in Argentina and Depositors(per 1000 adults) in Ecuador?
Give a very brief answer. 202.45. In the year 2009, what is the difference between the Depositors(per 1000 adults) in Small states and Depositors(per 1000 adults) in Sub-Saharan Africa (all income levels)?
Your answer should be very brief. 74.76. In the year 2009, what is the difference between the Depositors(per 1000 adults) of Small states and Depositors(per 1000 adults) of Argentina?
Ensure brevity in your answer.  -515.31. In the year 2009, what is the difference between the Depositors(per 1000 adults) in Small states and Depositors(per 1000 adults) in Ecuador?
Give a very brief answer. -223.48. In the year 2009, what is the difference between the Depositors(per 1000 adults) of Sub-Saharan Africa (all income levels) and Depositors(per 1000 adults) of Argentina?
Provide a short and direct response. -590.08. In the year 2009, what is the difference between the Depositors(per 1000 adults) in Sub-Saharan Africa (all income levels) and Depositors(per 1000 adults) in Ecuador?
Your answer should be very brief. -298.24. In the year 2009, what is the difference between the Depositors(per 1000 adults) of Argentina and Depositors(per 1000 adults) of Ecuador?
Give a very brief answer. 291.83. In the year 2010, what is the difference between the Depositors(per 1000 adults) in Small states and Depositors(per 1000 adults) in Sub-Saharan Africa (all income levels)?
Offer a terse response. 67.72. In the year 2010, what is the difference between the Depositors(per 1000 adults) of Small states and Depositors(per 1000 adults) of Argentina?
Your answer should be compact. -525.16. In the year 2010, what is the difference between the Depositors(per 1000 adults) in Small states and Depositors(per 1000 adults) in Ecuador?
Keep it short and to the point. -345.15. In the year 2010, what is the difference between the Depositors(per 1000 adults) in Sub-Saharan Africa (all income levels) and Depositors(per 1000 adults) in Argentina?
Your answer should be very brief. -592.88. In the year 2010, what is the difference between the Depositors(per 1000 adults) in Sub-Saharan Africa (all income levels) and Depositors(per 1000 adults) in Ecuador?
Provide a succinct answer. -412.87. In the year 2010, what is the difference between the Depositors(per 1000 adults) in Argentina and Depositors(per 1000 adults) in Ecuador?
Ensure brevity in your answer.  180.01. In the year 2011, what is the difference between the Depositors(per 1000 adults) of Small states and Depositors(per 1000 adults) of Sub-Saharan Africa (all income levels)?
Your answer should be very brief. 245.76. In the year 2011, what is the difference between the Depositors(per 1000 adults) in Small states and Depositors(per 1000 adults) in Argentina?
Offer a terse response. -360.54. In the year 2011, what is the difference between the Depositors(per 1000 adults) of Small states and Depositors(per 1000 adults) of Ecuador?
Give a very brief answer. -241.07. In the year 2011, what is the difference between the Depositors(per 1000 adults) of Sub-Saharan Africa (all income levels) and Depositors(per 1000 adults) of Argentina?
Your answer should be very brief. -606.3. In the year 2011, what is the difference between the Depositors(per 1000 adults) of Sub-Saharan Africa (all income levels) and Depositors(per 1000 adults) of Ecuador?
Give a very brief answer. -486.83. In the year 2011, what is the difference between the Depositors(per 1000 adults) of Argentina and Depositors(per 1000 adults) of Ecuador?
Offer a terse response. 119.47. In the year 2012, what is the difference between the Depositors(per 1000 adults) of Small states and Depositors(per 1000 adults) of Sub-Saharan Africa (all income levels)?
Make the answer very short. 267.23. In the year 2012, what is the difference between the Depositors(per 1000 adults) in Small states and Depositors(per 1000 adults) in Argentina?
Ensure brevity in your answer.  -402.62. In the year 2012, what is the difference between the Depositors(per 1000 adults) of Small states and Depositors(per 1000 adults) of Ecuador?
Make the answer very short. -186. In the year 2012, what is the difference between the Depositors(per 1000 adults) of Sub-Saharan Africa (all income levels) and Depositors(per 1000 adults) of Argentina?
Offer a very short reply. -669.85. In the year 2012, what is the difference between the Depositors(per 1000 adults) of Sub-Saharan Africa (all income levels) and Depositors(per 1000 adults) of Ecuador?
Keep it short and to the point. -453.24. In the year 2012, what is the difference between the Depositors(per 1000 adults) in Argentina and Depositors(per 1000 adults) in Ecuador?
Keep it short and to the point. 216.61. What is the ratio of the Depositors(per 1000 adults) of Small states in 2005 to that in 2006?
Offer a very short reply. 0.82. What is the ratio of the Depositors(per 1000 adults) of Sub-Saharan Africa (all income levels) in 2005 to that in 2006?
Your answer should be compact. 0.97. What is the ratio of the Depositors(per 1000 adults) in Argentina in 2005 to that in 2006?
Offer a very short reply. 0.93. What is the ratio of the Depositors(per 1000 adults) in Ecuador in 2005 to that in 2006?
Offer a very short reply. 0.95. What is the ratio of the Depositors(per 1000 adults) in Small states in 2005 to that in 2007?
Your response must be concise. 1.49. What is the ratio of the Depositors(per 1000 adults) in Sub-Saharan Africa (all income levels) in 2005 to that in 2007?
Ensure brevity in your answer.  0.8. What is the ratio of the Depositors(per 1000 adults) in Argentina in 2005 to that in 2007?
Your response must be concise. 0.83. What is the ratio of the Depositors(per 1000 adults) in Ecuador in 2005 to that in 2007?
Keep it short and to the point. 0.93. What is the ratio of the Depositors(per 1000 adults) of Small states in 2005 to that in 2008?
Your answer should be very brief. 1.82. What is the ratio of the Depositors(per 1000 adults) in Sub-Saharan Africa (all income levels) in 2005 to that in 2008?
Your response must be concise. 0.71. What is the ratio of the Depositors(per 1000 adults) of Argentina in 2005 to that in 2008?
Provide a succinct answer. 0.81. What is the ratio of the Depositors(per 1000 adults) of Ecuador in 2005 to that in 2008?
Provide a short and direct response. 0.81. What is the ratio of the Depositors(per 1000 adults) in Small states in 2005 to that in 2009?
Your answer should be very brief. 1.68. What is the ratio of the Depositors(per 1000 adults) of Sub-Saharan Africa (all income levels) in 2005 to that in 2009?
Provide a succinct answer. 0.65. What is the ratio of the Depositors(per 1000 adults) of Argentina in 2005 to that in 2009?
Your answer should be compact. 0.74. What is the ratio of the Depositors(per 1000 adults) in Ecuador in 2005 to that in 2009?
Ensure brevity in your answer.  0.87. What is the ratio of the Depositors(per 1000 adults) in Small states in 2005 to that in 2010?
Provide a short and direct response. 1.6. What is the ratio of the Depositors(per 1000 adults) of Sub-Saharan Africa (all income levels) in 2005 to that in 2010?
Ensure brevity in your answer.  0.56. What is the ratio of the Depositors(per 1000 adults) of Argentina in 2005 to that in 2010?
Offer a very short reply. 0.73. What is the ratio of the Depositors(per 1000 adults) in Ecuador in 2005 to that in 2010?
Ensure brevity in your answer.  0.65. What is the ratio of the Depositors(per 1000 adults) in Small states in 2005 to that in 2011?
Your answer should be very brief. 0.76. What is the ratio of the Depositors(per 1000 adults) of Sub-Saharan Africa (all income levels) in 2005 to that in 2011?
Provide a short and direct response. 0.5. What is the ratio of the Depositors(per 1000 adults) of Argentina in 2005 to that in 2011?
Your response must be concise. 0.7. What is the ratio of the Depositors(per 1000 adults) of Ecuador in 2005 to that in 2011?
Keep it short and to the point. 0.56. What is the ratio of the Depositors(per 1000 adults) of Small states in 2005 to that in 2012?
Your answer should be very brief. 0.69. What is the ratio of the Depositors(per 1000 adults) in Sub-Saharan Africa (all income levels) in 2005 to that in 2012?
Offer a terse response. 0.43. What is the ratio of the Depositors(per 1000 adults) of Argentina in 2005 to that in 2012?
Your answer should be very brief. 0.63. What is the ratio of the Depositors(per 1000 adults) in Ecuador in 2005 to that in 2012?
Keep it short and to the point. 0.57. What is the ratio of the Depositors(per 1000 adults) of Small states in 2006 to that in 2007?
Keep it short and to the point. 1.81. What is the ratio of the Depositors(per 1000 adults) in Sub-Saharan Africa (all income levels) in 2006 to that in 2007?
Offer a terse response. 0.83. What is the ratio of the Depositors(per 1000 adults) in Argentina in 2006 to that in 2007?
Your answer should be compact. 0.9. What is the ratio of the Depositors(per 1000 adults) in Ecuador in 2006 to that in 2007?
Ensure brevity in your answer.  0.98. What is the ratio of the Depositors(per 1000 adults) in Small states in 2006 to that in 2008?
Offer a terse response. 2.21. What is the ratio of the Depositors(per 1000 adults) of Sub-Saharan Africa (all income levels) in 2006 to that in 2008?
Your answer should be compact. 0.73. What is the ratio of the Depositors(per 1000 adults) in Argentina in 2006 to that in 2008?
Your answer should be very brief. 0.88. What is the ratio of the Depositors(per 1000 adults) in Ecuador in 2006 to that in 2008?
Keep it short and to the point. 0.84. What is the ratio of the Depositors(per 1000 adults) of Small states in 2006 to that in 2009?
Provide a short and direct response. 2.03. What is the ratio of the Depositors(per 1000 adults) of Sub-Saharan Africa (all income levels) in 2006 to that in 2009?
Make the answer very short. 0.66. What is the ratio of the Depositors(per 1000 adults) of Argentina in 2006 to that in 2009?
Offer a very short reply. 0.8. What is the ratio of the Depositors(per 1000 adults) in Ecuador in 2006 to that in 2009?
Ensure brevity in your answer.  0.91. What is the ratio of the Depositors(per 1000 adults) of Small states in 2006 to that in 2010?
Offer a terse response. 1.94. What is the ratio of the Depositors(per 1000 adults) of Sub-Saharan Africa (all income levels) in 2006 to that in 2010?
Make the answer very short. 0.57. What is the ratio of the Depositors(per 1000 adults) of Argentina in 2006 to that in 2010?
Offer a terse response. 0.78. What is the ratio of the Depositors(per 1000 adults) of Ecuador in 2006 to that in 2010?
Make the answer very short. 0.68. What is the ratio of the Depositors(per 1000 adults) in Small states in 2006 to that in 2011?
Your answer should be compact. 0.93. What is the ratio of the Depositors(per 1000 adults) in Sub-Saharan Africa (all income levels) in 2006 to that in 2011?
Provide a succinct answer. 0.51. What is the ratio of the Depositors(per 1000 adults) of Argentina in 2006 to that in 2011?
Offer a very short reply. 0.76. What is the ratio of the Depositors(per 1000 adults) in Ecuador in 2006 to that in 2011?
Offer a terse response. 0.59. What is the ratio of the Depositors(per 1000 adults) in Small states in 2006 to that in 2012?
Provide a succinct answer. 0.84. What is the ratio of the Depositors(per 1000 adults) in Sub-Saharan Africa (all income levels) in 2006 to that in 2012?
Offer a terse response. 0.44. What is the ratio of the Depositors(per 1000 adults) of Argentina in 2006 to that in 2012?
Give a very brief answer. 0.68. What is the ratio of the Depositors(per 1000 adults) of Ecuador in 2006 to that in 2012?
Provide a succinct answer. 0.6. What is the ratio of the Depositors(per 1000 adults) in Small states in 2007 to that in 2008?
Provide a succinct answer. 1.22. What is the ratio of the Depositors(per 1000 adults) in Sub-Saharan Africa (all income levels) in 2007 to that in 2008?
Offer a very short reply. 0.88. What is the ratio of the Depositors(per 1000 adults) of Argentina in 2007 to that in 2008?
Your answer should be very brief. 0.98. What is the ratio of the Depositors(per 1000 adults) of Ecuador in 2007 to that in 2008?
Make the answer very short. 0.86. What is the ratio of the Depositors(per 1000 adults) of Small states in 2007 to that in 2009?
Keep it short and to the point. 1.12. What is the ratio of the Depositors(per 1000 adults) of Sub-Saharan Africa (all income levels) in 2007 to that in 2009?
Ensure brevity in your answer.  0.8. What is the ratio of the Depositors(per 1000 adults) of Argentina in 2007 to that in 2009?
Your answer should be very brief. 0.89. What is the ratio of the Depositors(per 1000 adults) of Ecuador in 2007 to that in 2009?
Make the answer very short. 0.93. What is the ratio of the Depositors(per 1000 adults) in Small states in 2007 to that in 2010?
Your response must be concise. 1.07. What is the ratio of the Depositors(per 1000 adults) in Sub-Saharan Africa (all income levels) in 2007 to that in 2010?
Offer a very short reply. 0.69. What is the ratio of the Depositors(per 1000 adults) of Argentina in 2007 to that in 2010?
Give a very brief answer. 0.87. What is the ratio of the Depositors(per 1000 adults) of Ecuador in 2007 to that in 2010?
Provide a succinct answer. 0.7. What is the ratio of the Depositors(per 1000 adults) in Small states in 2007 to that in 2011?
Your response must be concise. 0.51. What is the ratio of the Depositors(per 1000 adults) of Sub-Saharan Africa (all income levels) in 2007 to that in 2011?
Provide a succinct answer. 0.62. What is the ratio of the Depositors(per 1000 adults) of Argentina in 2007 to that in 2011?
Give a very brief answer. 0.84. What is the ratio of the Depositors(per 1000 adults) of Ecuador in 2007 to that in 2011?
Give a very brief answer. 0.6. What is the ratio of the Depositors(per 1000 adults) of Small states in 2007 to that in 2012?
Provide a succinct answer. 0.46. What is the ratio of the Depositors(per 1000 adults) of Sub-Saharan Africa (all income levels) in 2007 to that in 2012?
Provide a short and direct response. 0.54. What is the ratio of the Depositors(per 1000 adults) in Argentina in 2007 to that in 2012?
Your answer should be very brief. 0.75. What is the ratio of the Depositors(per 1000 adults) of Ecuador in 2007 to that in 2012?
Offer a terse response. 0.61. What is the ratio of the Depositors(per 1000 adults) of Small states in 2008 to that in 2009?
Provide a succinct answer. 0.92. What is the ratio of the Depositors(per 1000 adults) in Sub-Saharan Africa (all income levels) in 2008 to that in 2009?
Your answer should be compact. 0.91. What is the ratio of the Depositors(per 1000 adults) of Argentina in 2008 to that in 2009?
Provide a succinct answer. 0.91. What is the ratio of the Depositors(per 1000 adults) of Ecuador in 2008 to that in 2009?
Offer a terse response. 1.08. What is the ratio of the Depositors(per 1000 adults) of Small states in 2008 to that in 2010?
Your answer should be compact. 0.88. What is the ratio of the Depositors(per 1000 adults) in Sub-Saharan Africa (all income levels) in 2008 to that in 2010?
Offer a very short reply. 0.78. What is the ratio of the Depositors(per 1000 adults) of Argentina in 2008 to that in 2010?
Your answer should be very brief. 0.89. What is the ratio of the Depositors(per 1000 adults) of Ecuador in 2008 to that in 2010?
Your response must be concise. 0.81. What is the ratio of the Depositors(per 1000 adults) of Small states in 2008 to that in 2011?
Your answer should be very brief. 0.42. What is the ratio of the Depositors(per 1000 adults) in Sub-Saharan Africa (all income levels) in 2008 to that in 2011?
Your response must be concise. 0.7. What is the ratio of the Depositors(per 1000 adults) in Argentina in 2008 to that in 2011?
Give a very brief answer. 0.86. What is the ratio of the Depositors(per 1000 adults) of Ecuador in 2008 to that in 2011?
Give a very brief answer. 0.69. What is the ratio of the Depositors(per 1000 adults) in Small states in 2008 to that in 2012?
Offer a very short reply. 0.38. What is the ratio of the Depositors(per 1000 adults) in Sub-Saharan Africa (all income levels) in 2008 to that in 2012?
Provide a succinct answer. 0.61. What is the ratio of the Depositors(per 1000 adults) in Argentina in 2008 to that in 2012?
Provide a short and direct response. 0.77. What is the ratio of the Depositors(per 1000 adults) of Ecuador in 2008 to that in 2012?
Offer a terse response. 0.71. What is the ratio of the Depositors(per 1000 adults) in Small states in 2009 to that in 2010?
Provide a short and direct response. 0.95. What is the ratio of the Depositors(per 1000 adults) in Sub-Saharan Africa (all income levels) in 2009 to that in 2010?
Offer a terse response. 0.86. What is the ratio of the Depositors(per 1000 adults) of Argentina in 2009 to that in 2010?
Make the answer very short. 0.97. What is the ratio of the Depositors(per 1000 adults) of Ecuador in 2009 to that in 2010?
Provide a succinct answer. 0.75. What is the ratio of the Depositors(per 1000 adults) of Small states in 2009 to that in 2011?
Offer a very short reply. 0.46. What is the ratio of the Depositors(per 1000 adults) in Sub-Saharan Africa (all income levels) in 2009 to that in 2011?
Your response must be concise. 0.77. What is the ratio of the Depositors(per 1000 adults) in Argentina in 2009 to that in 2011?
Provide a succinct answer. 0.94. What is the ratio of the Depositors(per 1000 adults) of Ecuador in 2009 to that in 2011?
Offer a very short reply. 0.64. What is the ratio of the Depositors(per 1000 adults) in Small states in 2009 to that in 2012?
Provide a succinct answer. 0.41. What is the ratio of the Depositors(per 1000 adults) of Sub-Saharan Africa (all income levels) in 2009 to that in 2012?
Give a very brief answer. 0.67. What is the ratio of the Depositors(per 1000 adults) in Argentina in 2009 to that in 2012?
Make the answer very short. 0.84. What is the ratio of the Depositors(per 1000 adults) in Ecuador in 2009 to that in 2012?
Your answer should be compact. 0.66. What is the ratio of the Depositors(per 1000 adults) in Small states in 2010 to that in 2011?
Your answer should be compact. 0.48. What is the ratio of the Depositors(per 1000 adults) in Sub-Saharan Africa (all income levels) in 2010 to that in 2011?
Provide a short and direct response. 0.9. What is the ratio of the Depositors(per 1000 adults) in Argentina in 2010 to that in 2011?
Provide a short and direct response. 0.96. What is the ratio of the Depositors(per 1000 adults) of Ecuador in 2010 to that in 2011?
Your answer should be compact. 0.86. What is the ratio of the Depositors(per 1000 adults) in Small states in 2010 to that in 2012?
Keep it short and to the point. 0.43. What is the ratio of the Depositors(per 1000 adults) of Sub-Saharan Africa (all income levels) in 2010 to that in 2012?
Your response must be concise. 0.78. What is the ratio of the Depositors(per 1000 adults) in Argentina in 2010 to that in 2012?
Provide a succinct answer. 0.87. What is the ratio of the Depositors(per 1000 adults) of Ecuador in 2010 to that in 2012?
Offer a terse response. 0.88. What is the ratio of the Depositors(per 1000 adults) in Small states in 2011 to that in 2012?
Keep it short and to the point. 0.9. What is the ratio of the Depositors(per 1000 adults) of Sub-Saharan Africa (all income levels) in 2011 to that in 2012?
Offer a very short reply. 0.87. What is the ratio of the Depositors(per 1000 adults) in Argentina in 2011 to that in 2012?
Provide a short and direct response. 0.9. What is the ratio of the Depositors(per 1000 adults) of Ecuador in 2011 to that in 2012?
Provide a succinct answer. 1.03. What is the difference between the highest and the second highest Depositors(per 1000 adults) of Small states?
Your answer should be very brief. 39.45. What is the difference between the highest and the second highest Depositors(per 1000 adults) in Sub-Saharan Africa (all income levels)?
Offer a terse response. 17.98. What is the difference between the highest and the second highest Depositors(per 1000 adults) of Argentina?
Your answer should be very brief. 81.53. What is the difference between the highest and the second highest Depositors(per 1000 adults) of Ecuador?
Your answer should be compact. 15.61. What is the difference between the highest and the lowest Depositors(per 1000 adults) in Small states?
Make the answer very short. 250.91. What is the difference between the highest and the lowest Depositors(per 1000 adults) of Sub-Saharan Africa (all income levels)?
Offer a terse response. 77.62. What is the difference between the highest and the lowest Depositors(per 1000 adults) of Argentina?
Keep it short and to the point. 299.2. What is the difference between the highest and the lowest Depositors(per 1000 adults) of Ecuador?
Ensure brevity in your answer.  267.29. 